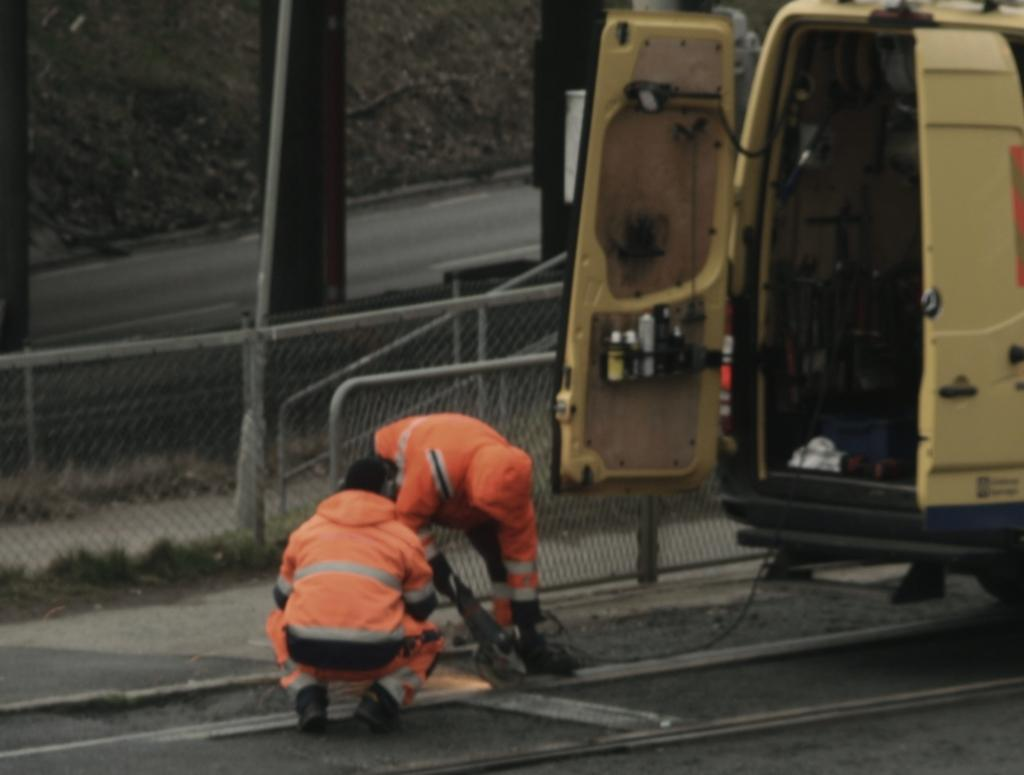How many people are in the image? There are two persons in the image. What are the persons doing in the image? The persons are doing work. What color are the uniforms worn by the persons in the image? The persons are wearing orange color uniforms. What type of vehicle can be seen in the image? There is a yellow-colored vehicle in the image. What can be seen in the background of the image? There is railing and poles visible in the background of the image. What grade did the persons in the image receive for their work? There is no indication of a grade or evaluation in the image, as it focuses on the persons doing work and their surroundings. 